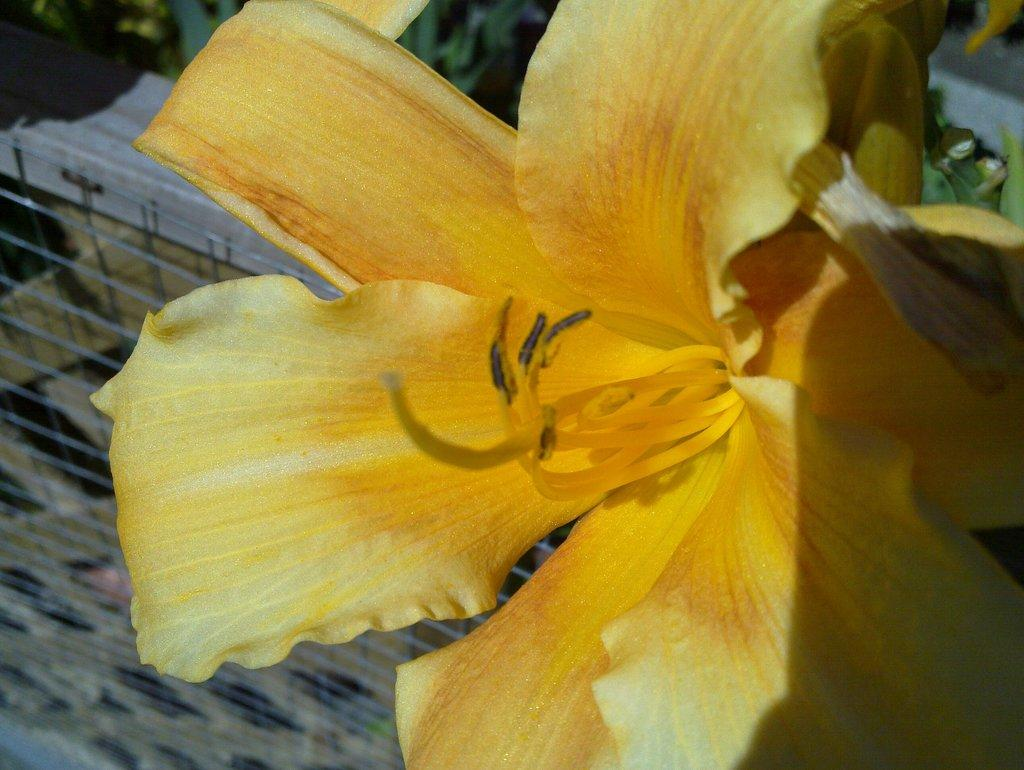What type of vegetation can be seen in the front of the image? There are flowers in the front of the image. What can be seen in the background of the image? There are plants and a net visible in the background of the image. What is the cause of the flowers growing in the image? There is no information provided about the cause of the flowers growing in the image. How many bikes are present in the image? There are no bikes present in the image. 